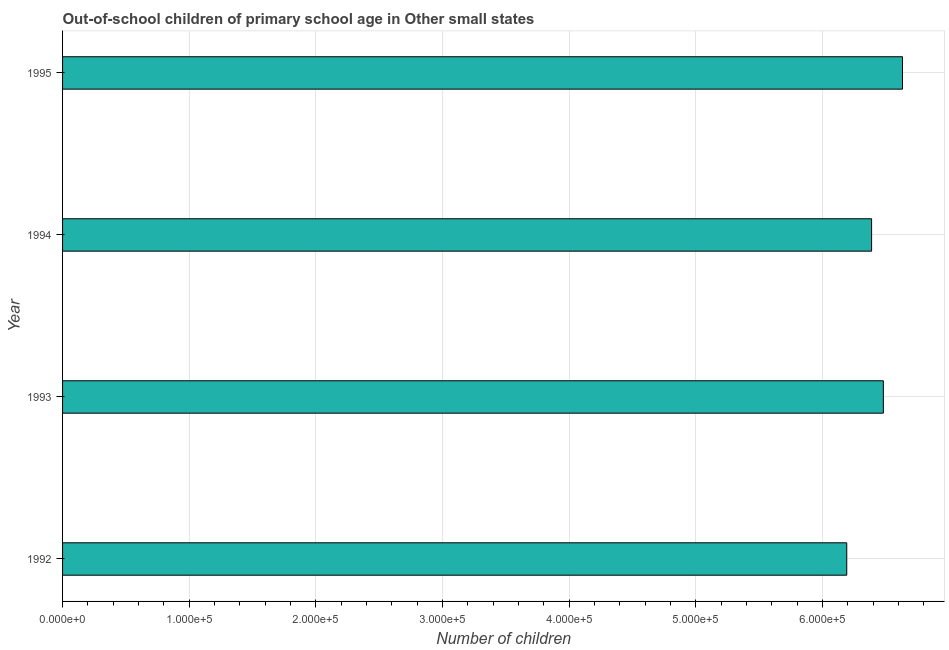Does the graph contain any zero values?
Offer a very short reply. No. What is the title of the graph?
Your answer should be very brief. Out-of-school children of primary school age in Other small states. What is the label or title of the X-axis?
Provide a succinct answer. Number of children. What is the label or title of the Y-axis?
Your answer should be very brief. Year. What is the number of out-of-school children in 1994?
Offer a terse response. 6.39e+05. Across all years, what is the maximum number of out-of-school children?
Give a very brief answer. 6.63e+05. Across all years, what is the minimum number of out-of-school children?
Your response must be concise. 6.19e+05. In which year was the number of out-of-school children minimum?
Keep it short and to the point. 1992. What is the sum of the number of out-of-school children?
Make the answer very short. 2.57e+06. What is the difference between the number of out-of-school children in 1993 and 1995?
Offer a very short reply. -1.51e+04. What is the average number of out-of-school children per year?
Make the answer very short. 6.42e+05. What is the median number of out-of-school children?
Offer a terse response. 6.43e+05. Do a majority of the years between 1993 and 1994 (inclusive) have number of out-of-school children greater than 280000 ?
Your answer should be very brief. Yes. What is the ratio of the number of out-of-school children in 1993 to that in 1994?
Make the answer very short. 1.01. Is the number of out-of-school children in 1992 less than that in 1993?
Make the answer very short. Yes. What is the difference between the highest and the second highest number of out-of-school children?
Provide a succinct answer. 1.51e+04. What is the difference between the highest and the lowest number of out-of-school children?
Make the answer very short. 4.40e+04. In how many years, is the number of out-of-school children greater than the average number of out-of-school children taken over all years?
Your answer should be very brief. 2. Are all the bars in the graph horizontal?
Offer a very short reply. Yes. How many years are there in the graph?
Give a very brief answer. 4. Are the values on the major ticks of X-axis written in scientific E-notation?
Your response must be concise. Yes. What is the Number of children of 1992?
Give a very brief answer. 6.19e+05. What is the Number of children of 1993?
Your response must be concise. 6.48e+05. What is the Number of children in 1994?
Keep it short and to the point. 6.39e+05. What is the Number of children of 1995?
Make the answer very short. 6.63e+05. What is the difference between the Number of children in 1992 and 1993?
Keep it short and to the point. -2.89e+04. What is the difference between the Number of children in 1992 and 1994?
Make the answer very short. -1.96e+04. What is the difference between the Number of children in 1992 and 1995?
Your answer should be compact. -4.40e+04. What is the difference between the Number of children in 1993 and 1994?
Your answer should be very brief. 9279. What is the difference between the Number of children in 1993 and 1995?
Offer a terse response. -1.51e+04. What is the difference between the Number of children in 1994 and 1995?
Keep it short and to the point. -2.44e+04. What is the ratio of the Number of children in 1992 to that in 1993?
Your answer should be compact. 0.95. What is the ratio of the Number of children in 1992 to that in 1995?
Provide a succinct answer. 0.93. What is the ratio of the Number of children in 1993 to that in 1995?
Ensure brevity in your answer.  0.98. 